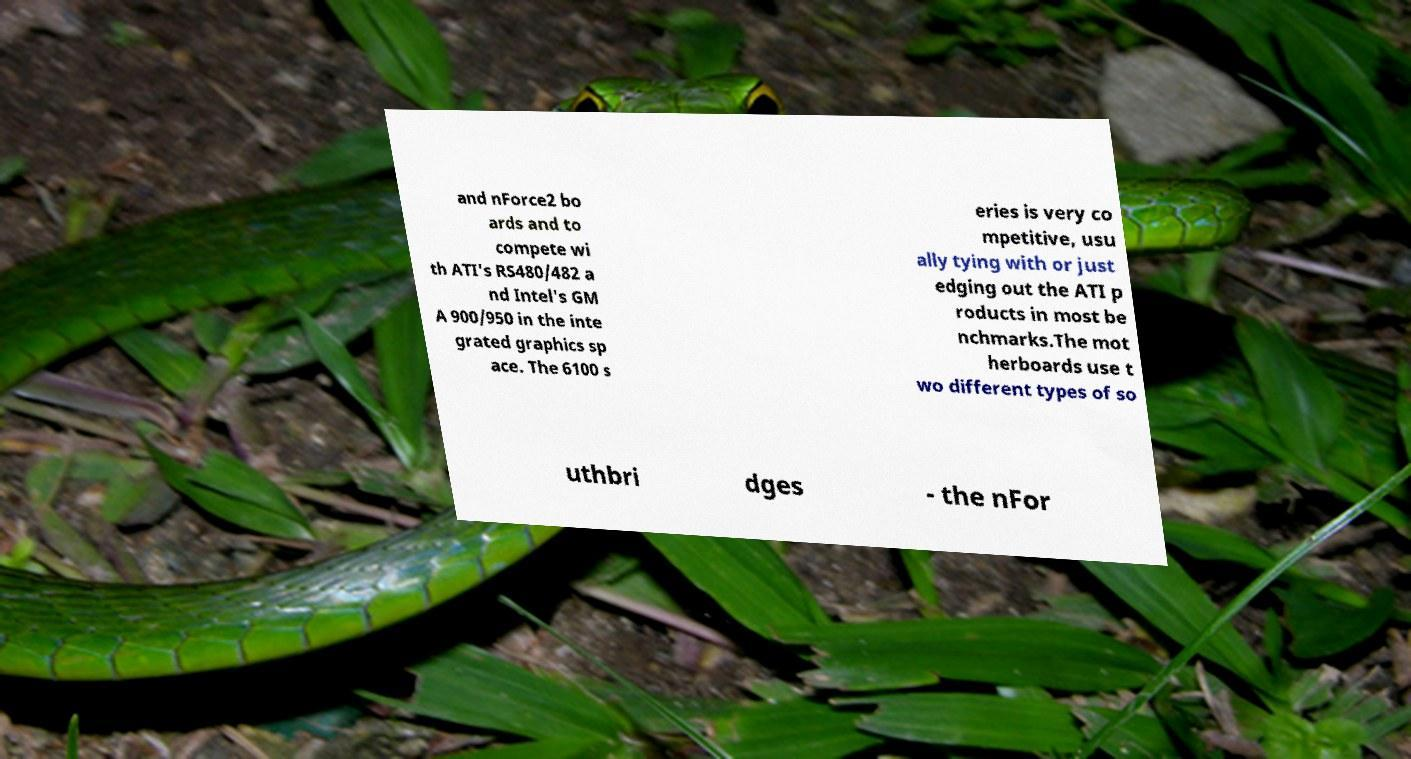Could you extract and type out the text from this image? and nForce2 bo ards and to compete wi th ATI's RS480/482 a nd Intel's GM A 900/950 in the inte grated graphics sp ace. The 6100 s eries is very co mpetitive, usu ally tying with or just edging out the ATI p roducts in most be nchmarks.The mot herboards use t wo different types of so uthbri dges - the nFor 